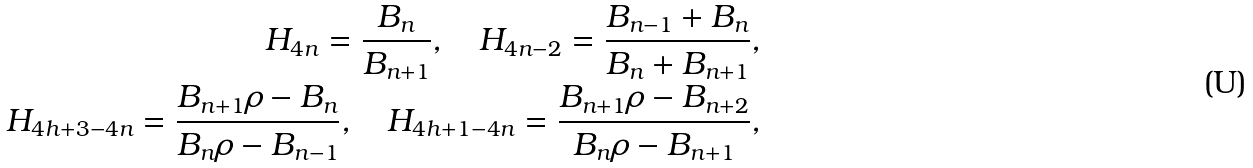Convert formula to latex. <formula><loc_0><loc_0><loc_500><loc_500>H _ { 4 n } = \frac { B _ { n } } { B _ { n + 1 } } , \quad H _ { 4 n - 2 } = \frac { B _ { n - 1 } + B _ { n } } { B _ { n } + B _ { n + 1 } } , \\ H _ { 4 h + 3 - 4 n } = \frac { B _ { n + 1 } \rho - B _ { n } } { B _ { n } \rho - B _ { n - 1 } } , \quad H _ { 4 h + 1 - 4 n } = \frac { B _ { n + 1 } \rho - B _ { n + 2 } } { B _ { n } \rho - B _ { n + 1 } } ,</formula> 